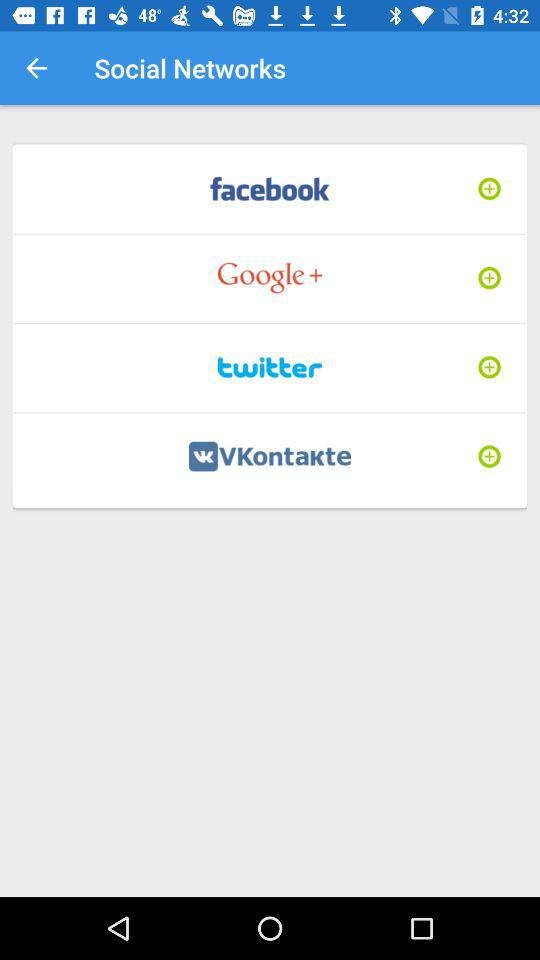What applications are mentioned in "Social Networks"? The applications are "facebook", "Google+", "twitter" and "VKontakte". 